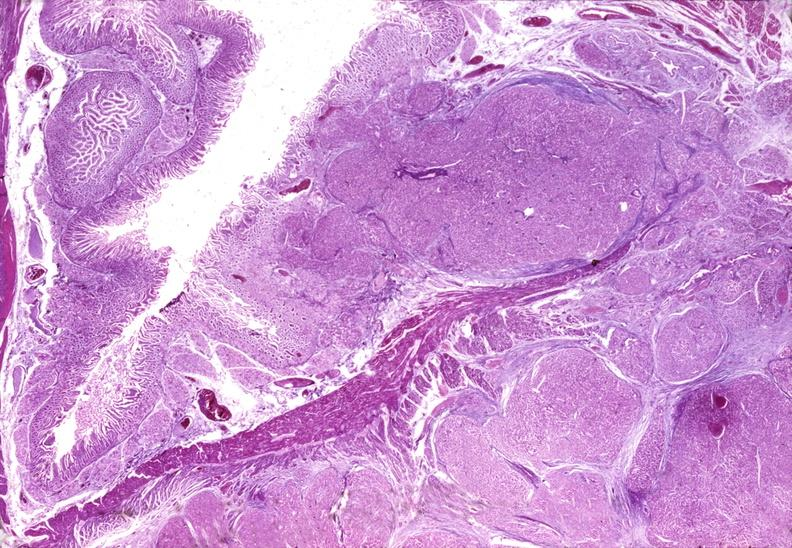what does this image show?
Answer the question using a single word or phrase. Islet cell carcinoma 